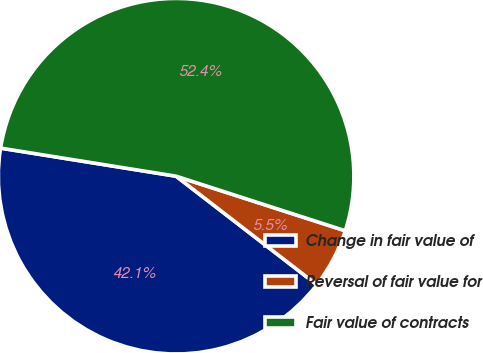<chart> <loc_0><loc_0><loc_500><loc_500><pie_chart><fcel>Change in fair value of<fcel>Reversal of fair value for<fcel>Fair value of contracts<nl><fcel>42.07%<fcel>5.49%<fcel>52.44%<nl></chart> 